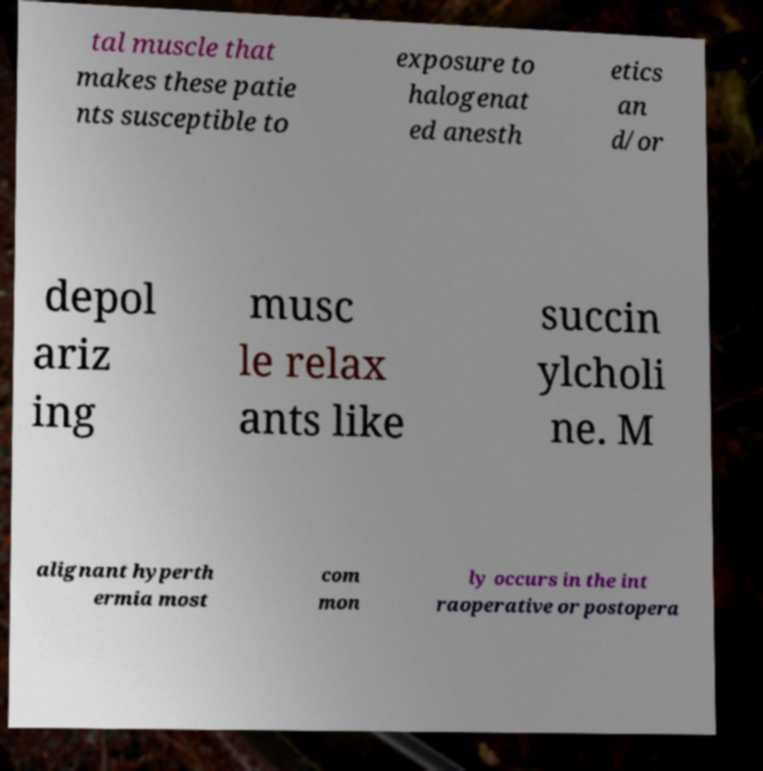Can you read and provide the text displayed in the image?This photo seems to have some interesting text. Can you extract and type it out for me? tal muscle that makes these patie nts susceptible to exposure to halogenat ed anesth etics an d/or depol ariz ing musc le relax ants like succin ylcholi ne. M alignant hyperth ermia most com mon ly occurs in the int raoperative or postopera 